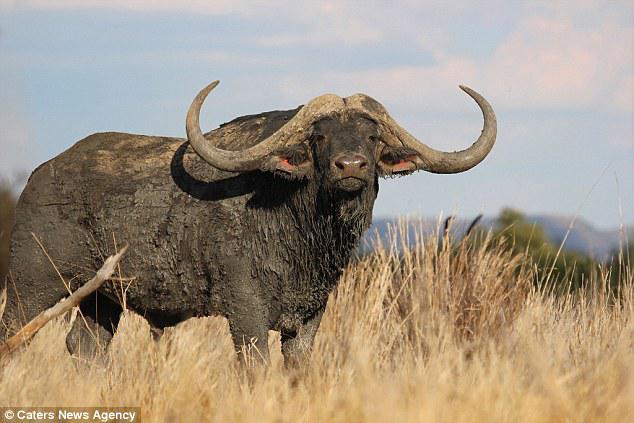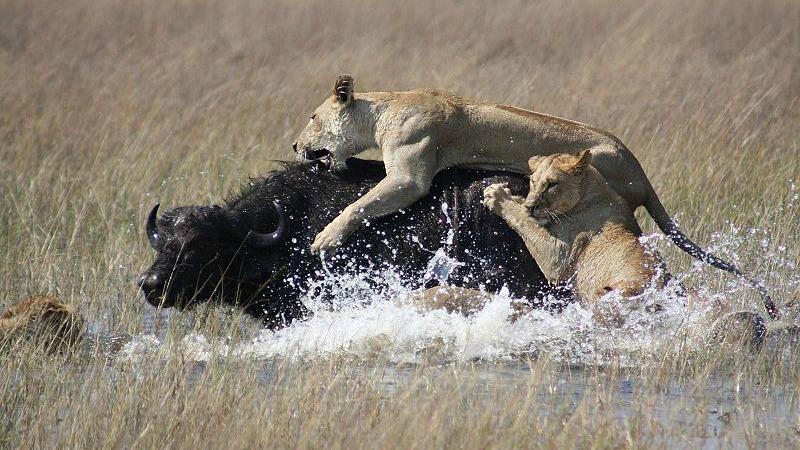The first image is the image on the left, the second image is the image on the right. Considering the images on both sides, is "The left image contains a sculpture of a water buffalo." valid? Answer yes or no. No. The first image is the image on the left, the second image is the image on the right. Analyze the images presented: Is the assertion "The left image contains a water buffalo with a bird standing on its back." valid? Answer yes or no. No. 